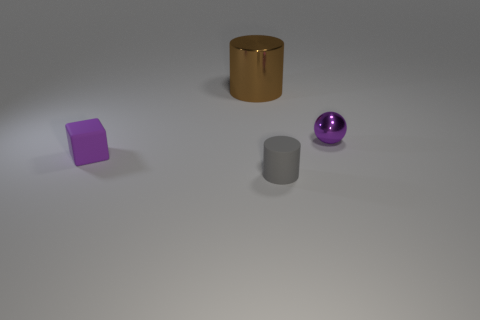Does the matte object that is on the right side of the large metallic object have the same size as the cylinder behind the small cylinder?
Your answer should be very brief. No. Is there a small rubber object that has the same shape as the large shiny object?
Your answer should be very brief. Yes. Are there fewer purple spheres that are in front of the shiny ball than purple blocks?
Offer a terse response. Yes. Do the small purple rubber thing and the tiny metal thing have the same shape?
Ensure brevity in your answer.  No. There is a matte object that is behind the tiny gray rubber cylinder; how big is it?
Provide a succinct answer. Small. There is a sphere that is the same material as the large cylinder; what size is it?
Provide a short and direct response. Small. Are there fewer balls than cylinders?
Offer a terse response. Yes. There is a sphere that is the same size as the purple block; what is it made of?
Your answer should be compact. Metal. Are there more large metal things than large yellow objects?
Your answer should be very brief. Yes. What number of other objects are the same color as the small matte block?
Offer a very short reply. 1. 